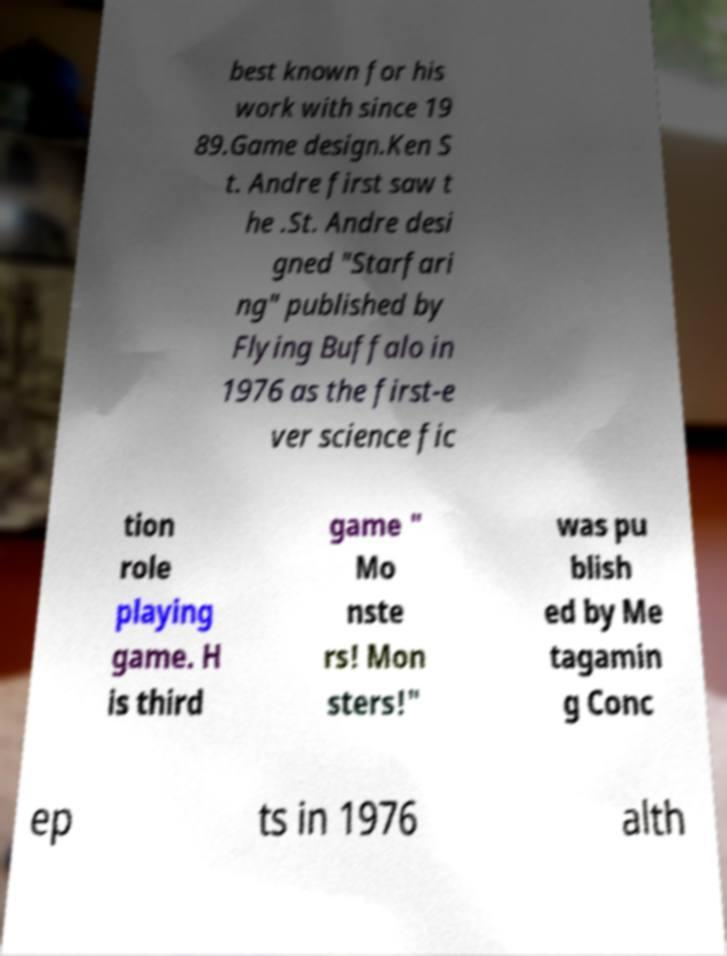There's text embedded in this image that I need extracted. Can you transcribe it verbatim? best known for his work with since 19 89.Game design.Ken S t. Andre first saw t he .St. Andre desi gned "Starfari ng" published by Flying Buffalo in 1976 as the first-e ver science fic tion role playing game. H is third game " Mo nste rs! Mon sters!" was pu blish ed by Me tagamin g Conc ep ts in 1976 alth 